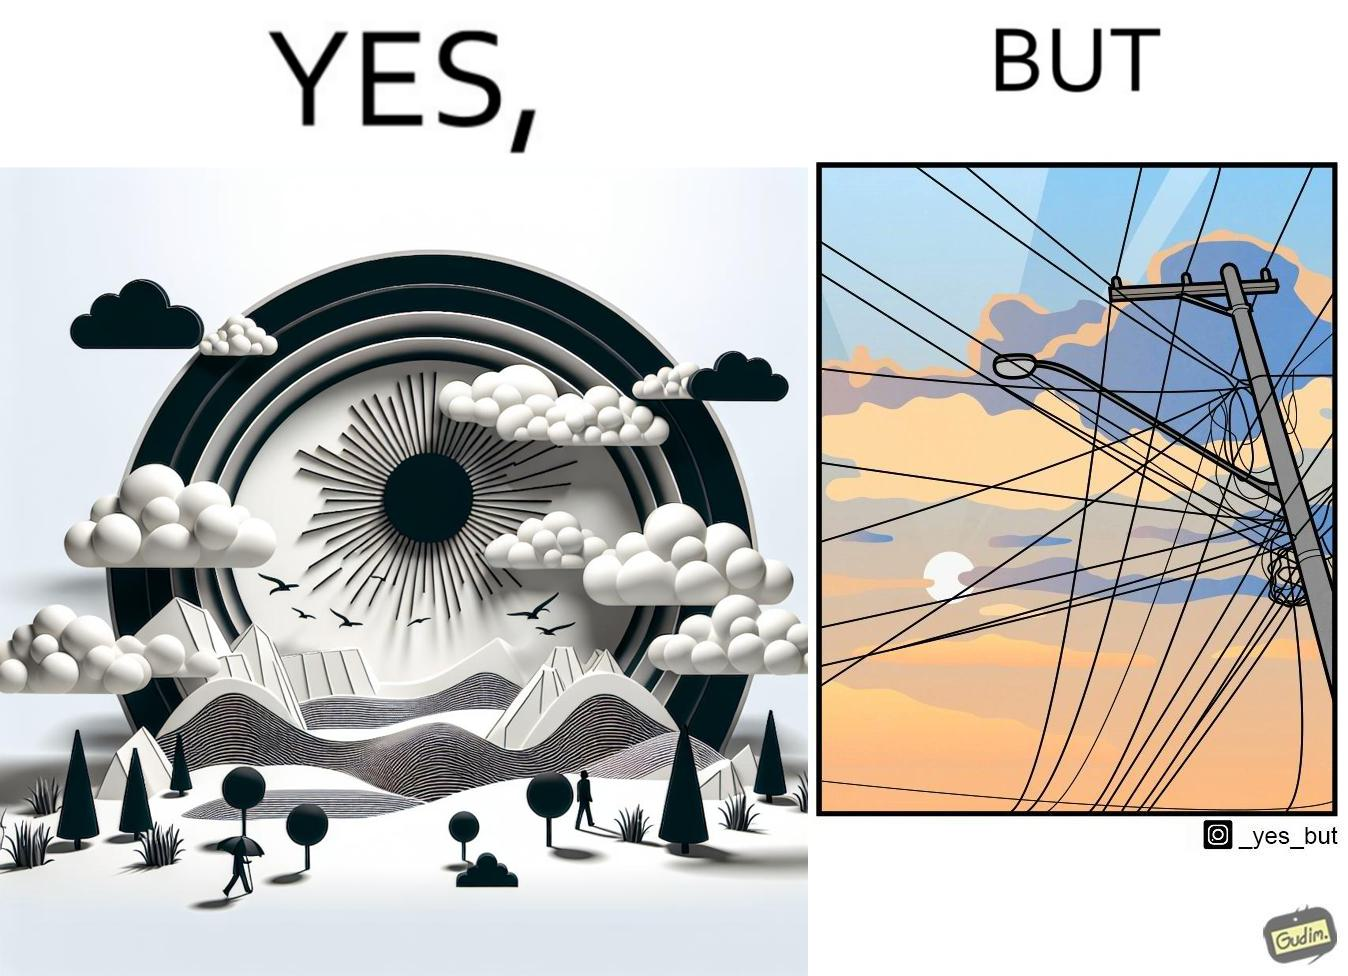Is this a satirical image? Yes, this image is satirical. 